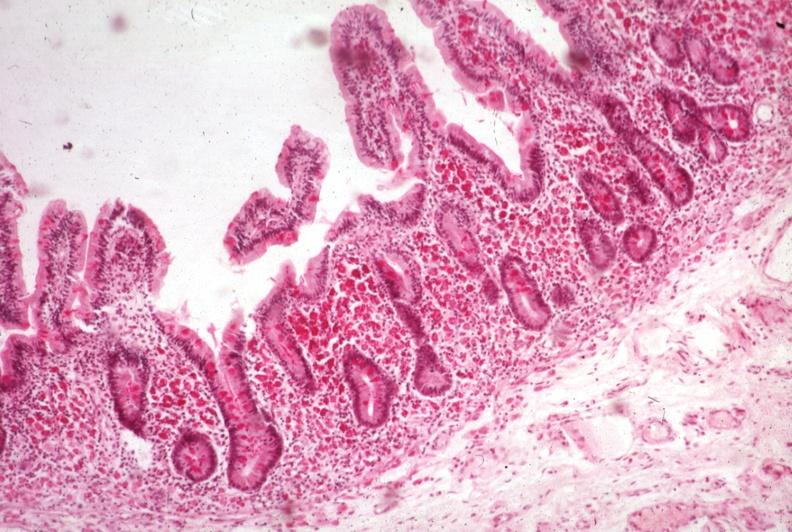does this image show pas hematoxylin?
Answer the question using a single word or phrase. Yes 